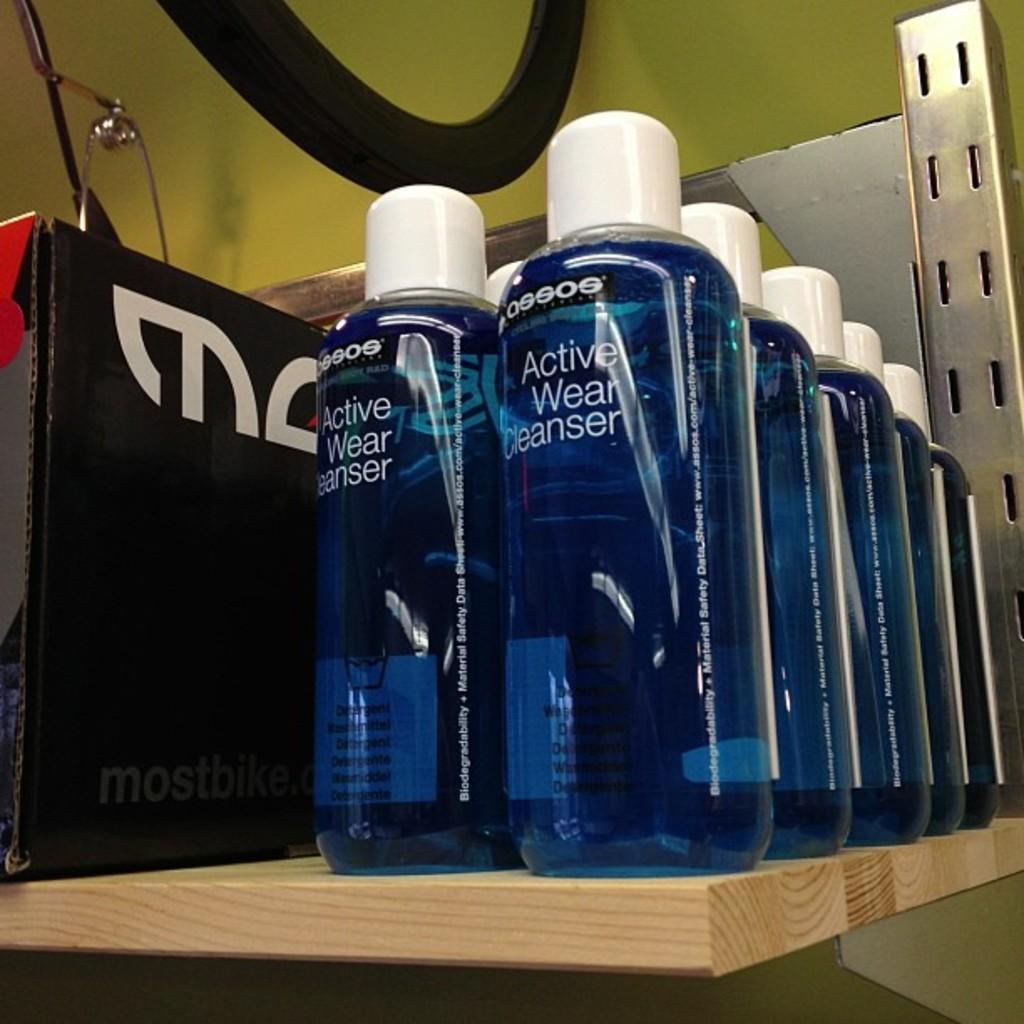<image>
Give a short and clear explanation of the subsequent image. A bottle of Active Wear Cleanser sits next to a box that says mostbike.com 